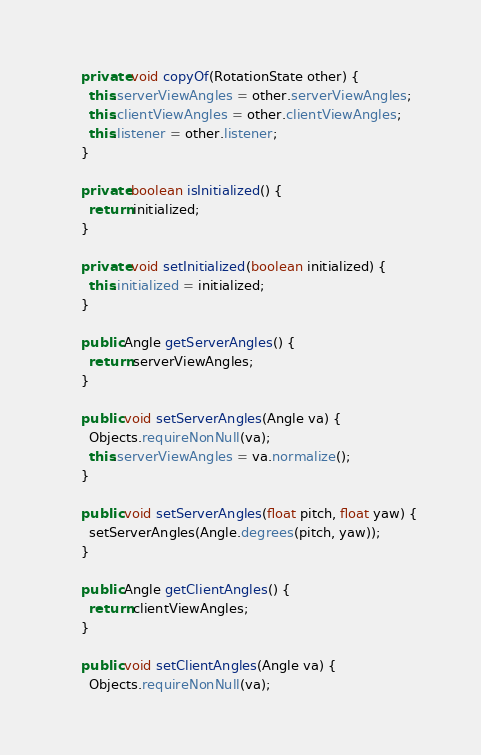Convert code to text. <code><loc_0><loc_0><loc_500><loc_500><_Java_>    private void copyOf(RotationState other) {
      this.serverViewAngles = other.serverViewAngles;
      this.clientViewAngles = other.clientViewAngles;
      this.listener = other.listener;
    }
    
    private boolean isInitialized() {
      return initialized;
    }
    
    private void setInitialized(boolean initialized) {
      this.initialized = initialized;
    }
    
    public Angle getServerAngles() {
      return serverViewAngles;
    }
    
    public void setServerAngles(Angle va) {
      Objects.requireNonNull(va);
      this.serverViewAngles = va.normalize();
    }
    
    public void setServerAngles(float pitch, float yaw) {
      setServerAngles(Angle.degrees(pitch, yaw));
    }
    
    public Angle getClientAngles() {
      return clientViewAngles;
    }
    
    public void setClientAngles(Angle va) {
      Objects.requireNonNull(va);</code> 